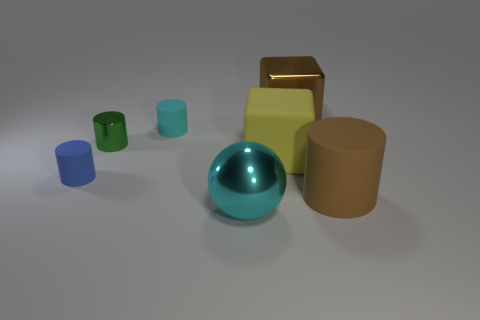Subtract all green cylinders. How many cylinders are left? 3 Subtract 1 cylinders. How many cylinders are left? 3 Add 1 cyan matte objects. How many objects exist? 8 Subtract all gray cylinders. Subtract all red blocks. How many cylinders are left? 4 Subtract all cylinders. How many objects are left? 3 Subtract 0 brown spheres. How many objects are left? 7 Subtract all cubes. Subtract all tiny things. How many objects are left? 2 Add 7 small green things. How many small green things are left? 8 Add 4 tiny green metallic cylinders. How many tiny green metallic cylinders exist? 5 